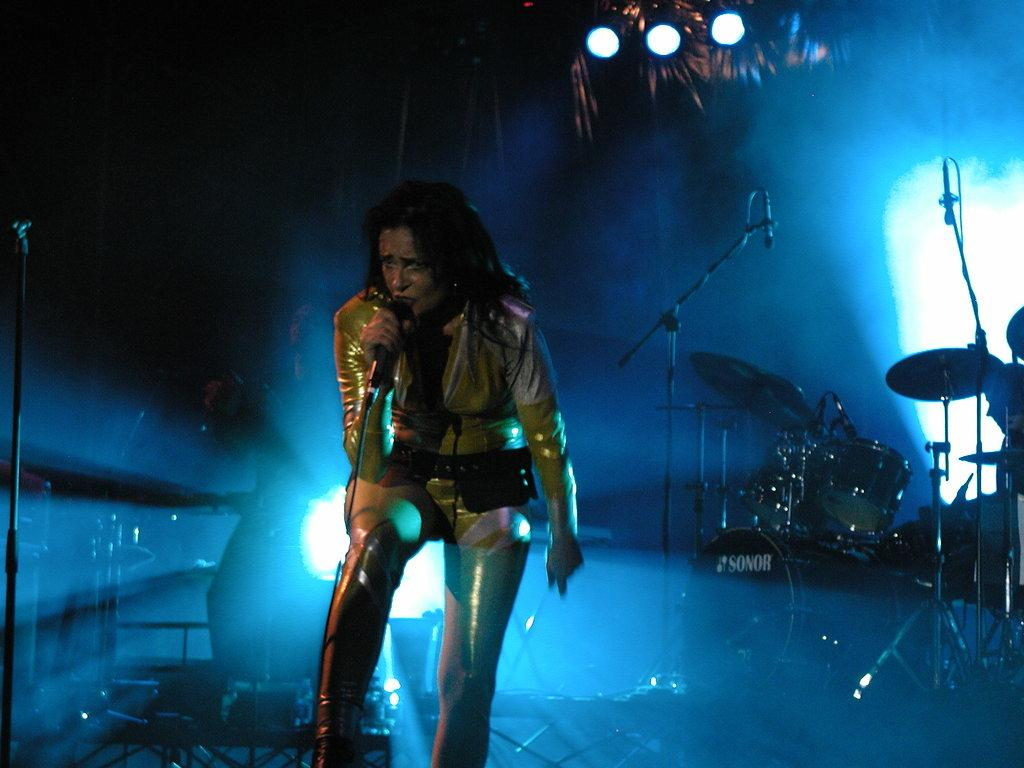What is the main subject of the image? The main subject of the image is a woman standing in the middle. What is the woman holding in the image? The woman is holding a microphone. What musical instruments are visible behind the woman? There are drums behind the woman. Are there any other microphones visible in the image? Yes, there are additional microphones behind the woman. What can be seen at the top of the image? There are lights visible at the top of the image. What type of writing can be seen on the silver farm equipment in the image? There is no writing on silver farm equipment present in the image. 